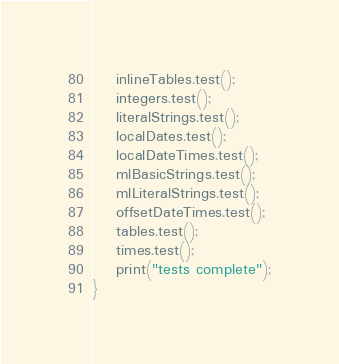Convert code to text. <code><loc_0><loc_0><loc_500><loc_500><_Ceylon_>    inlineTables.test();
    integers.test();
    literalStrings.test();
    localDates.test();
    localDateTimes.test();
    mlBasicStrings.test();
    mlLiteralStrings.test();
    offsetDateTimes.test();
    tables.test();
    times.test();
    print("tests complete");
}
</code> 